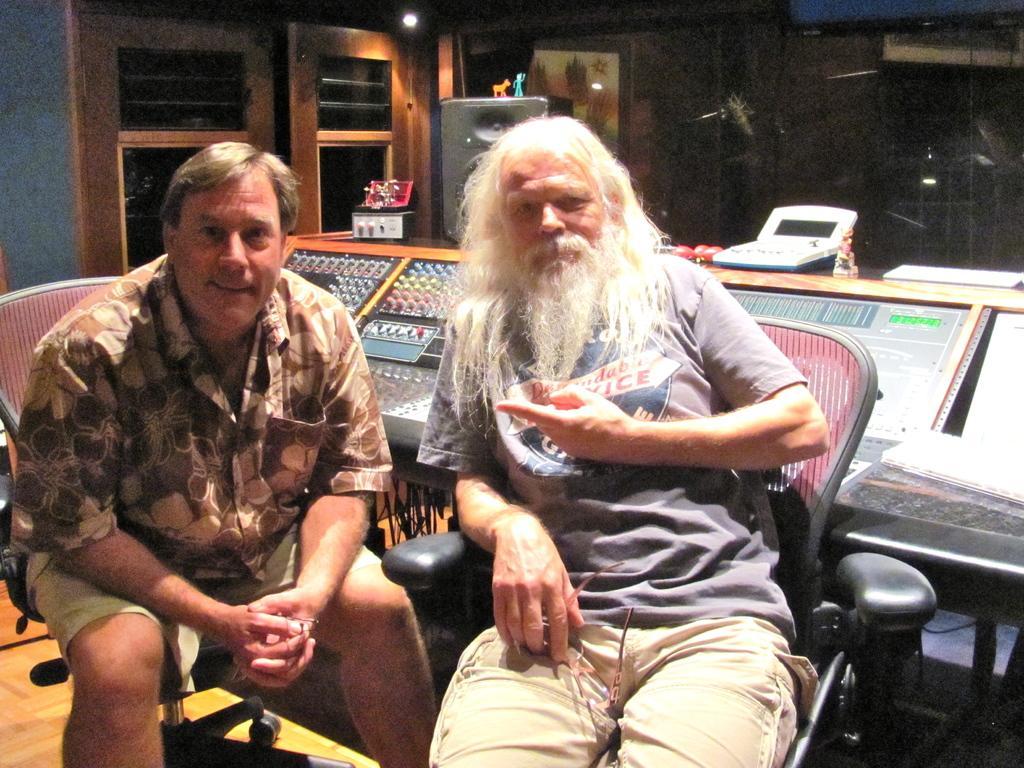Describe this image in one or two sentences. In the center of the image there are two people sitting on chairs. In the background of the image there is a door. 